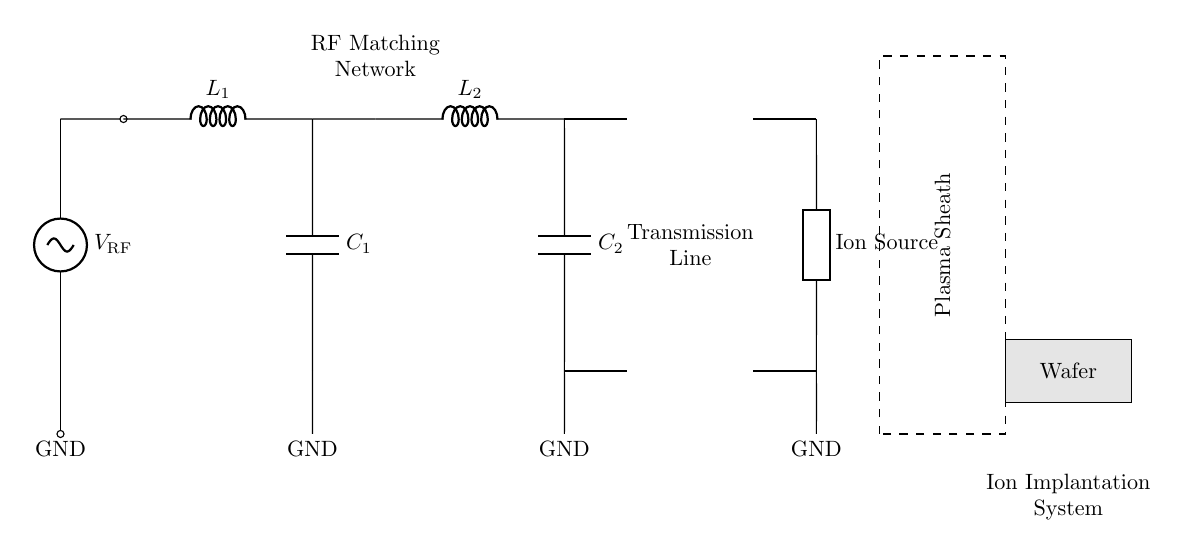What is the type of the first component in the circuit? The first component is a voltage source labeled as V_RF, which is the RF source providing the signal to the circuit.
Answer: Voltage source What is the value of the inductors used in the matching network? The circuit includes two inductors labeled L_1 and L_2, but no specific values are given in the diagram.
Answer: L_1 and L_2 How many capacitors are present in the matching network? There are two capacitors, C_1 and C_2, both positioned in the matching network portion of the circuit.
Answer: Two What device is represented at the output of the matching network? The output device is an ion source, depicted as a generic component extending downwards, which is a critical element in ion implantation systems.
Answer: Ion Source What is the function of the dashed rectangle in the circuit diagram? The dashed rectangle indicates the plasma sheath region, which is an important area in the ion implantation process where ions interact with the substrate.
Answer: Plasma Sheath How does the RF matching network optimize power transfer? The RF matching network's inductors and capacitors are arranged to match the impedance of the RF source to the load (ion source) for maximum power transfer, minimizing reflections.
Answer: Impedance matching 